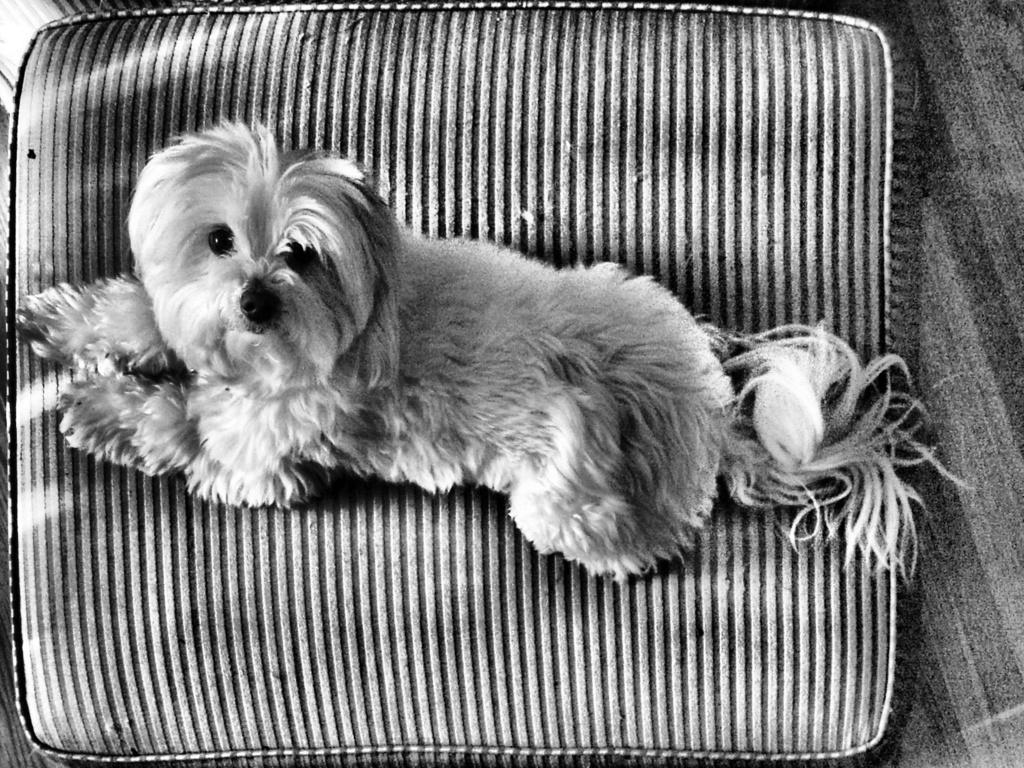What is the color scheme of the image? The image is black and white. What animal can be seen in the image? There is a dog in the image. Where is the dog located in the image? The dog is on a pillow. What type of sticks can be seen in the image? There are no sticks present in the image. Where is the library located in the image? There is no library present in the image. 